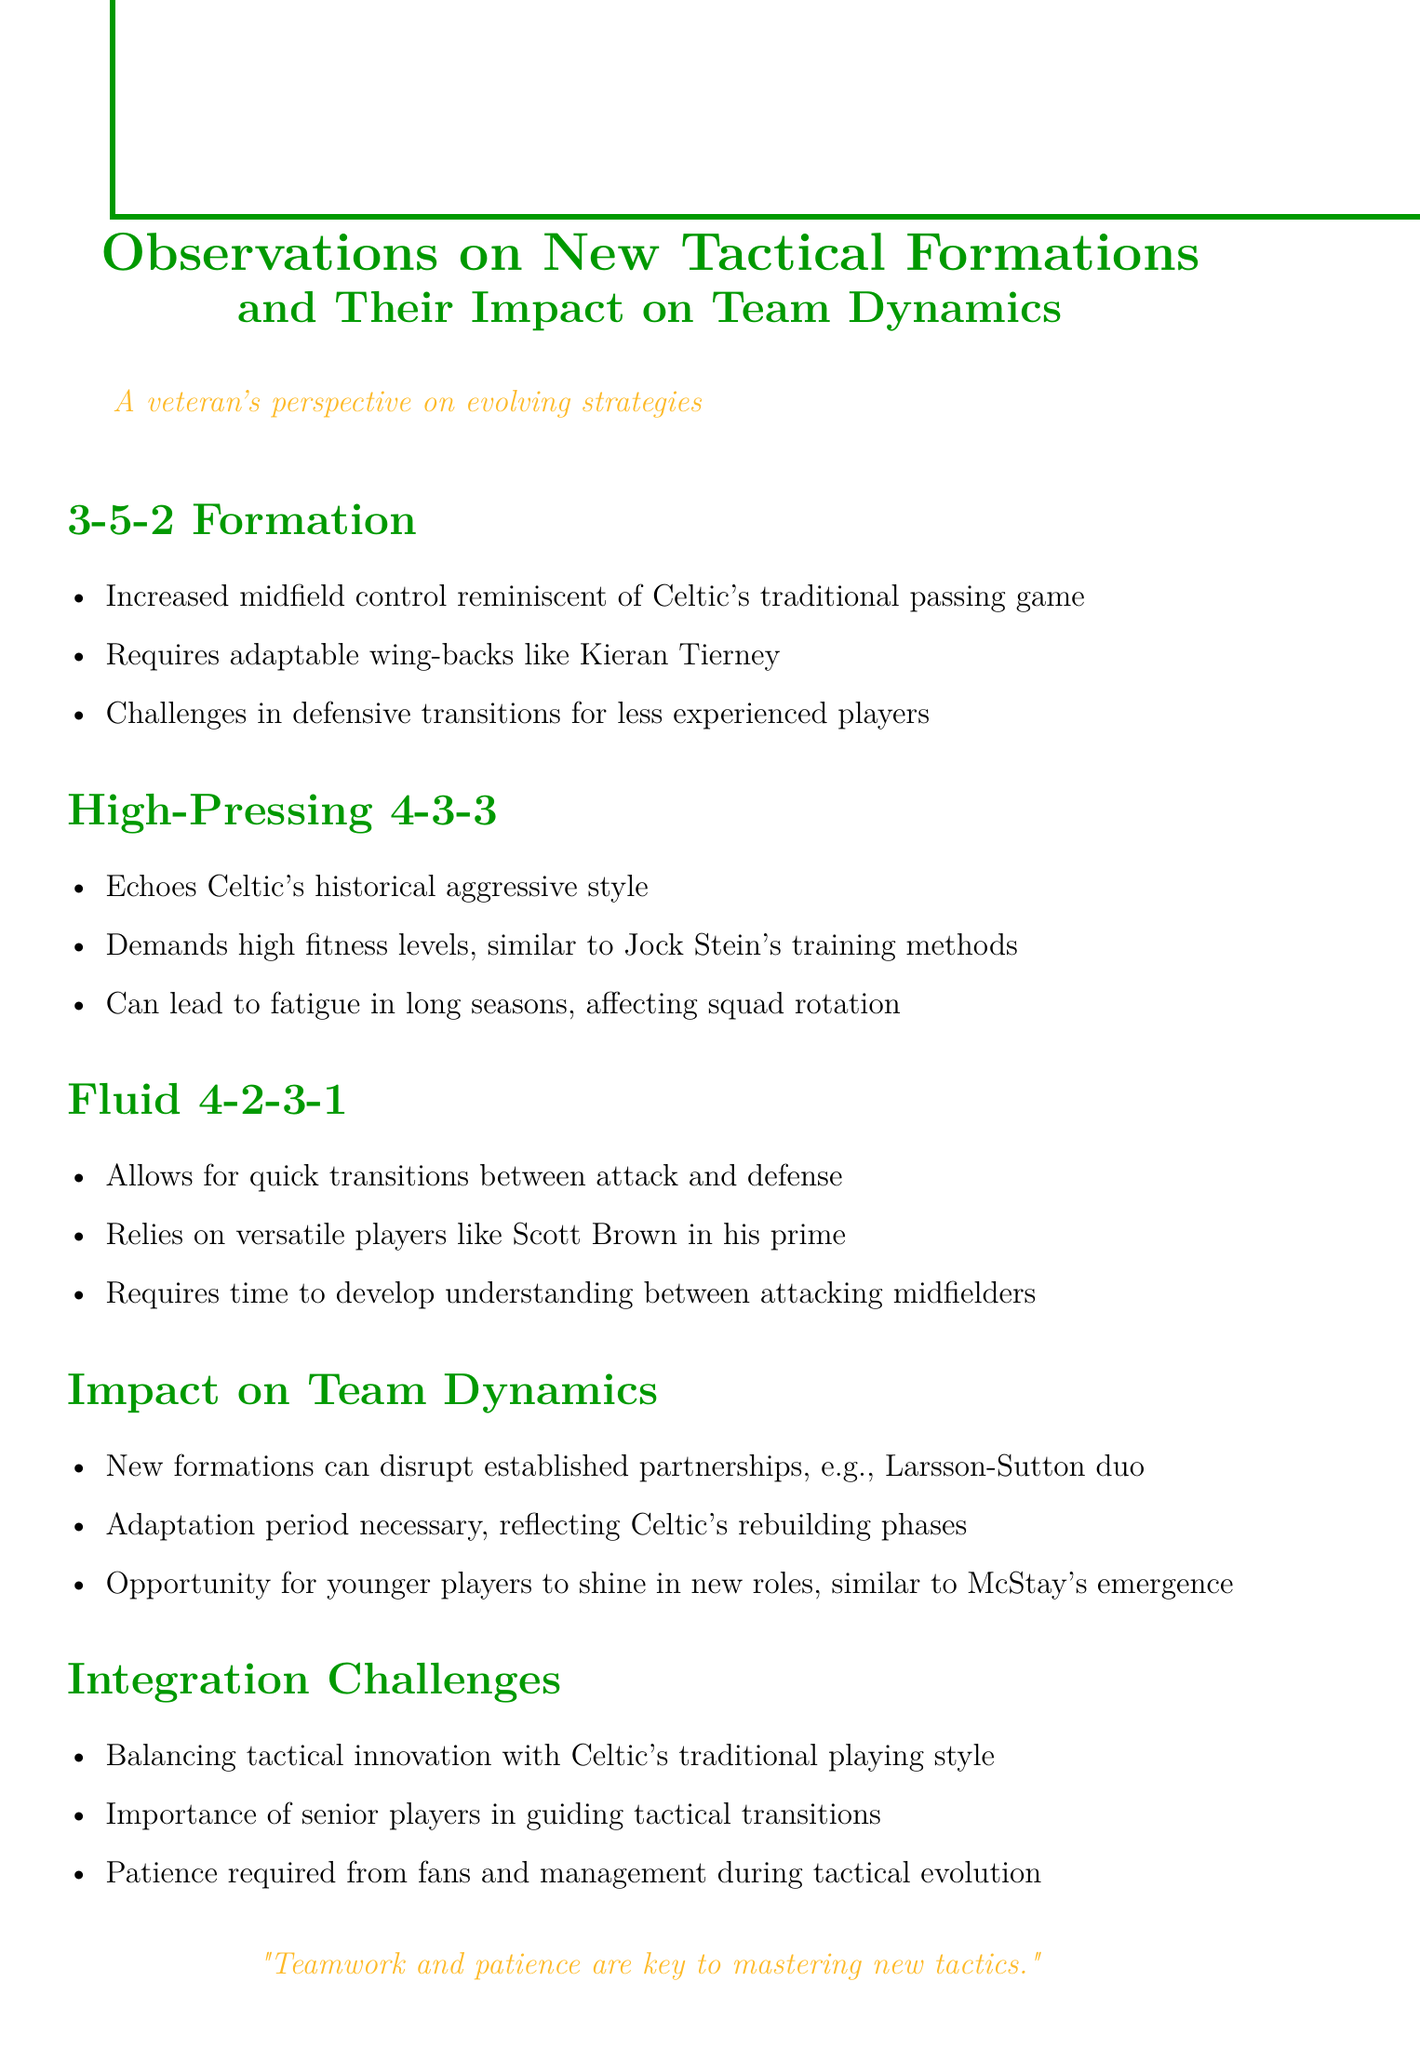What is the first tactical formation discussed? The document begins with the discussion of the 3-5-2 formation.
Answer: 3-5-2 Formation Which player is mentioned as an adaptable wing-back for the 3-5-2 formation? Kieran Tierney is highlighted as an adaptable wing-back in the context of the 3-5-2 formation.
Answer: Kieran Tierney What style does the High-Pressing 4-3-3 formation echo? The document states that this formation echoes Celtic's historical aggressive style.
Answer: Celtic's historical aggressive style What does the Fluid 4-2-3-1 formation allow for? It enables quick transitions between attack and defense, as per the observations in the document.
Answer: Quick transitions between attack and defense What impact do new formations have on established player partnerships? New formations can disrupt established partnerships, as illustrated by the example of the Larsson-Sutton duo.
Answer: Disrupt established partnerships What is emphasized as necessary during tactical evolution? The document mentions the need for patience from fans and management during tactical evolution.
Answer: Patience Which era's players does the document hint at when mentioning the importance of senior players? The text emphasizes the importance of senior players guiding tactical transitions, reminiscent of Celtic's historical periods.
Answer: Historical periods What is the key to mastering new tactics according to the document? The document concludes with an assertion that teamwork and patience are crucial for mastering new tactics.
Answer: Teamwork and patience 